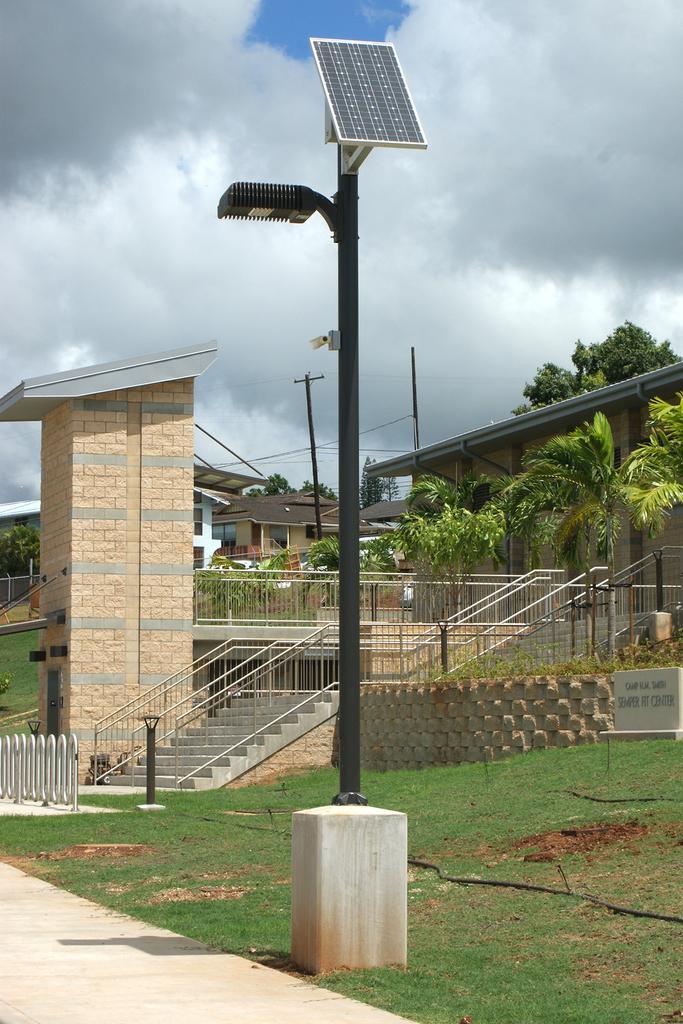Describe this image in one or two sentences. In this picture we can see a pole and a solar panel in the front, at the bottom there is grass, in the background there are some houses, we can see stairs and railings in the middle, on the right side there are some plants, in the background we can see trees, there is the sky and clouds at the top of the picture. 